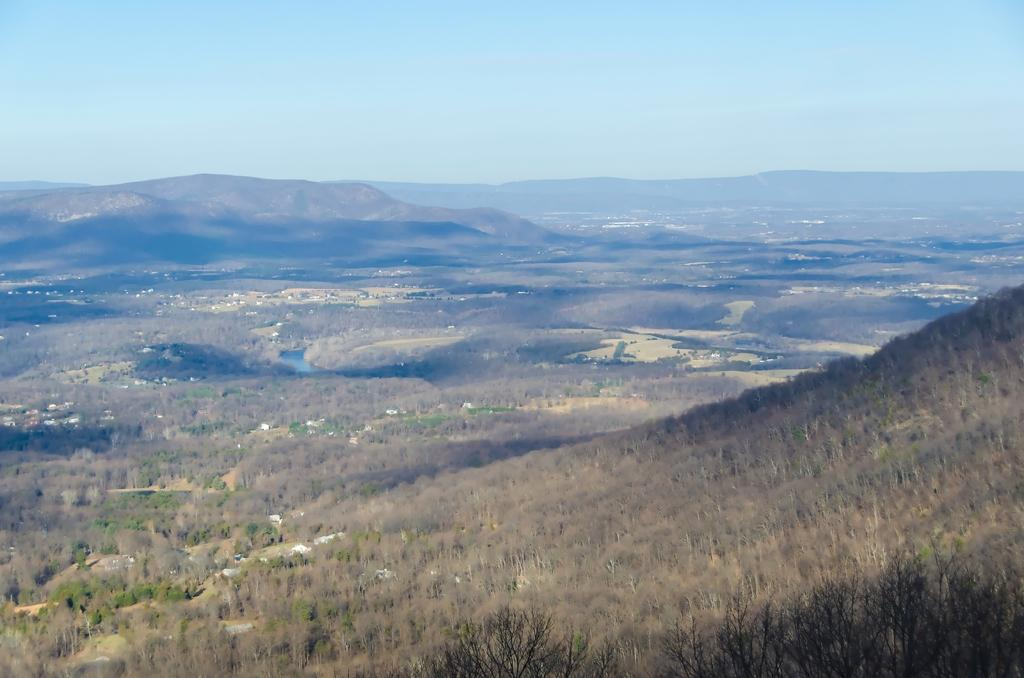What type of natural features can be seen in the image? There are trees and mountains in the image. What is visible in the background of the image? The sky is visible in the background of the image. What type of muscle can be seen flexing in the image? There is no muscle visible in the image; it features trees, mountains, and the sky. 